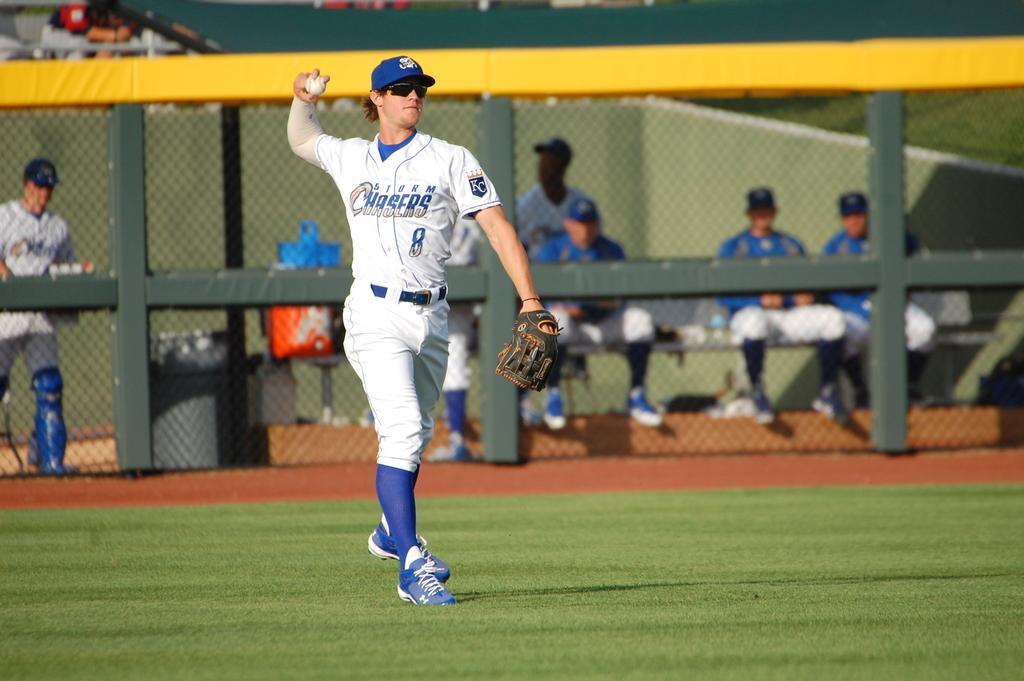Can you describe this image briefly? In this image in the center there is one person who is standing and he is holding a ball, and in the background there are some people some of them are sitting and some of them were standing. At the bottom there is grass, and in the background there is a net, wall and bench. On the bench there are some covers, beside the table there is a dustbin and on the top there are some poles and some persons. 